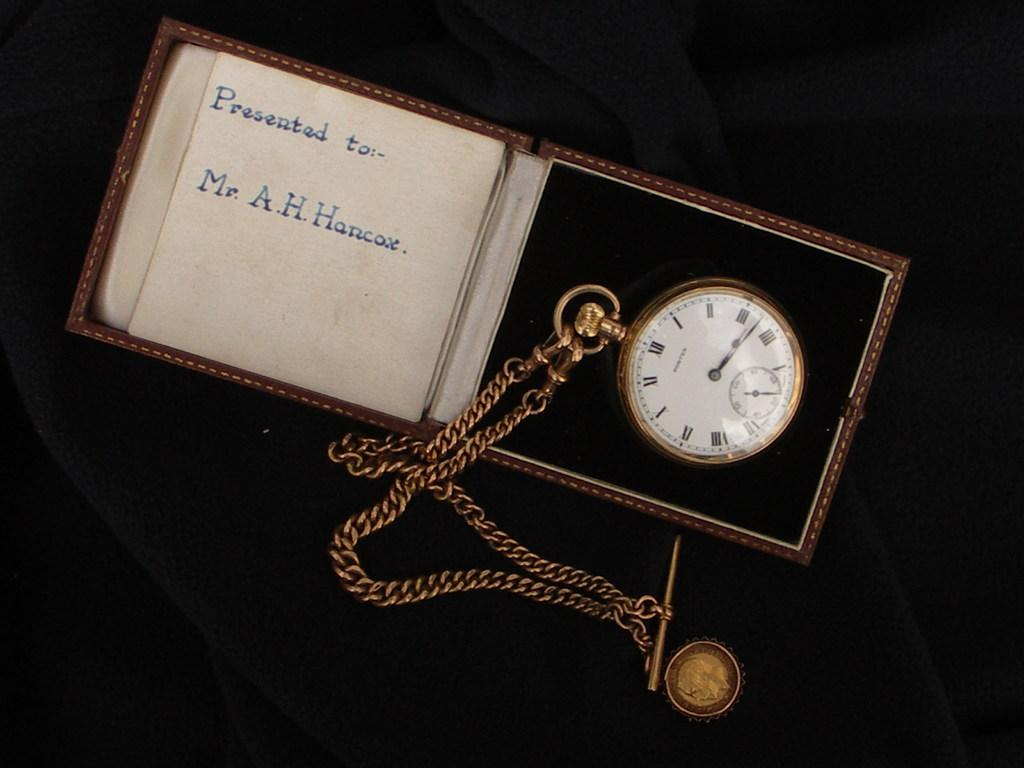Provide a one-sentence caption for the provided image. A clock in a box given to Mr. A, H. Hancox. 